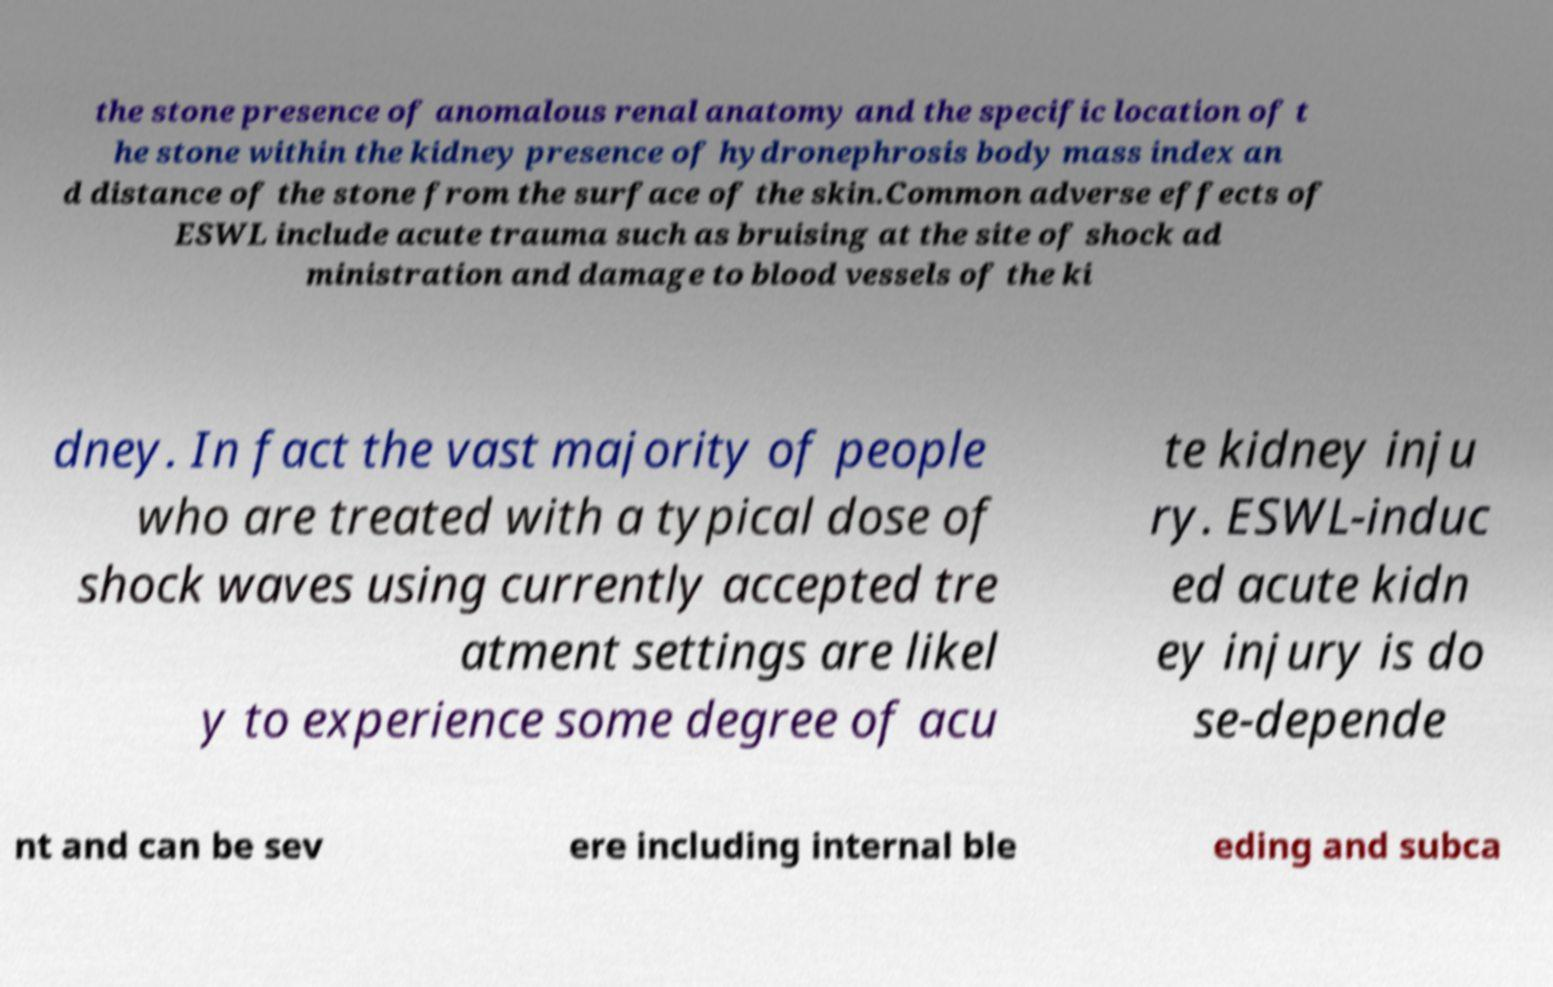There's text embedded in this image that I need extracted. Can you transcribe it verbatim? the stone presence of anomalous renal anatomy and the specific location of t he stone within the kidney presence of hydronephrosis body mass index an d distance of the stone from the surface of the skin.Common adverse effects of ESWL include acute trauma such as bruising at the site of shock ad ministration and damage to blood vessels of the ki dney. In fact the vast majority of people who are treated with a typical dose of shock waves using currently accepted tre atment settings are likel y to experience some degree of acu te kidney inju ry. ESWL-induc ed acute kidn ey injury is do se-depende nt and can be sev ere including internal ble eding and subca 